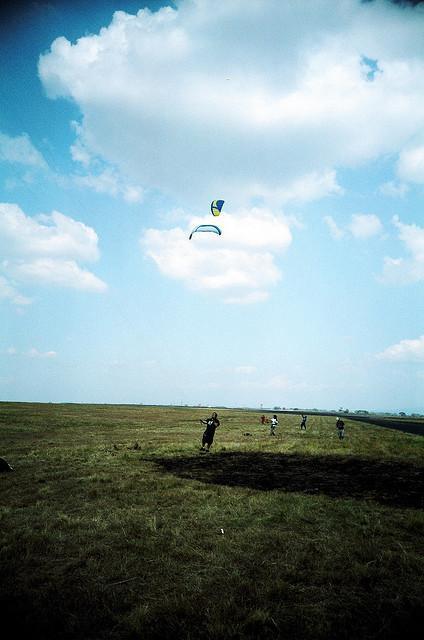How many kits are in the air?
Give a very brief answer. 2. How many dark umbrellas are there?
Give a very brief answer. 0. 